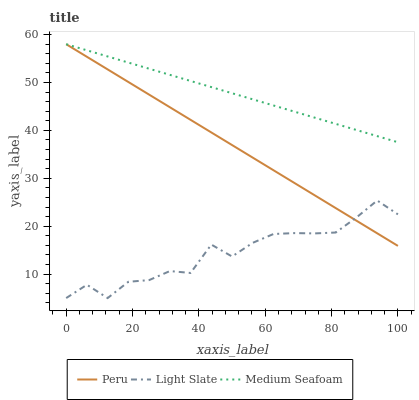Does Peru have the minimum area under the curve?
Answer yes or no. No. Does Peru have the maximum area under the curve?
Answer yes or no. No. Is Medium Seafoam the smoothest?
Answer yes or no. No. Is Medium Seafoam the roughest?
Answer yes or no. No. Does Peru have the lowest value?
Answer yes or no. No. Is Light Slate less than Medium Seafoam?
Answer yes or no. Yes. Is Medium Seafoam greater than Light Slate?
Answer yes or no. Yes. Does Light Slate intersect Medium Seafoam?
Answer yes or no. No. 